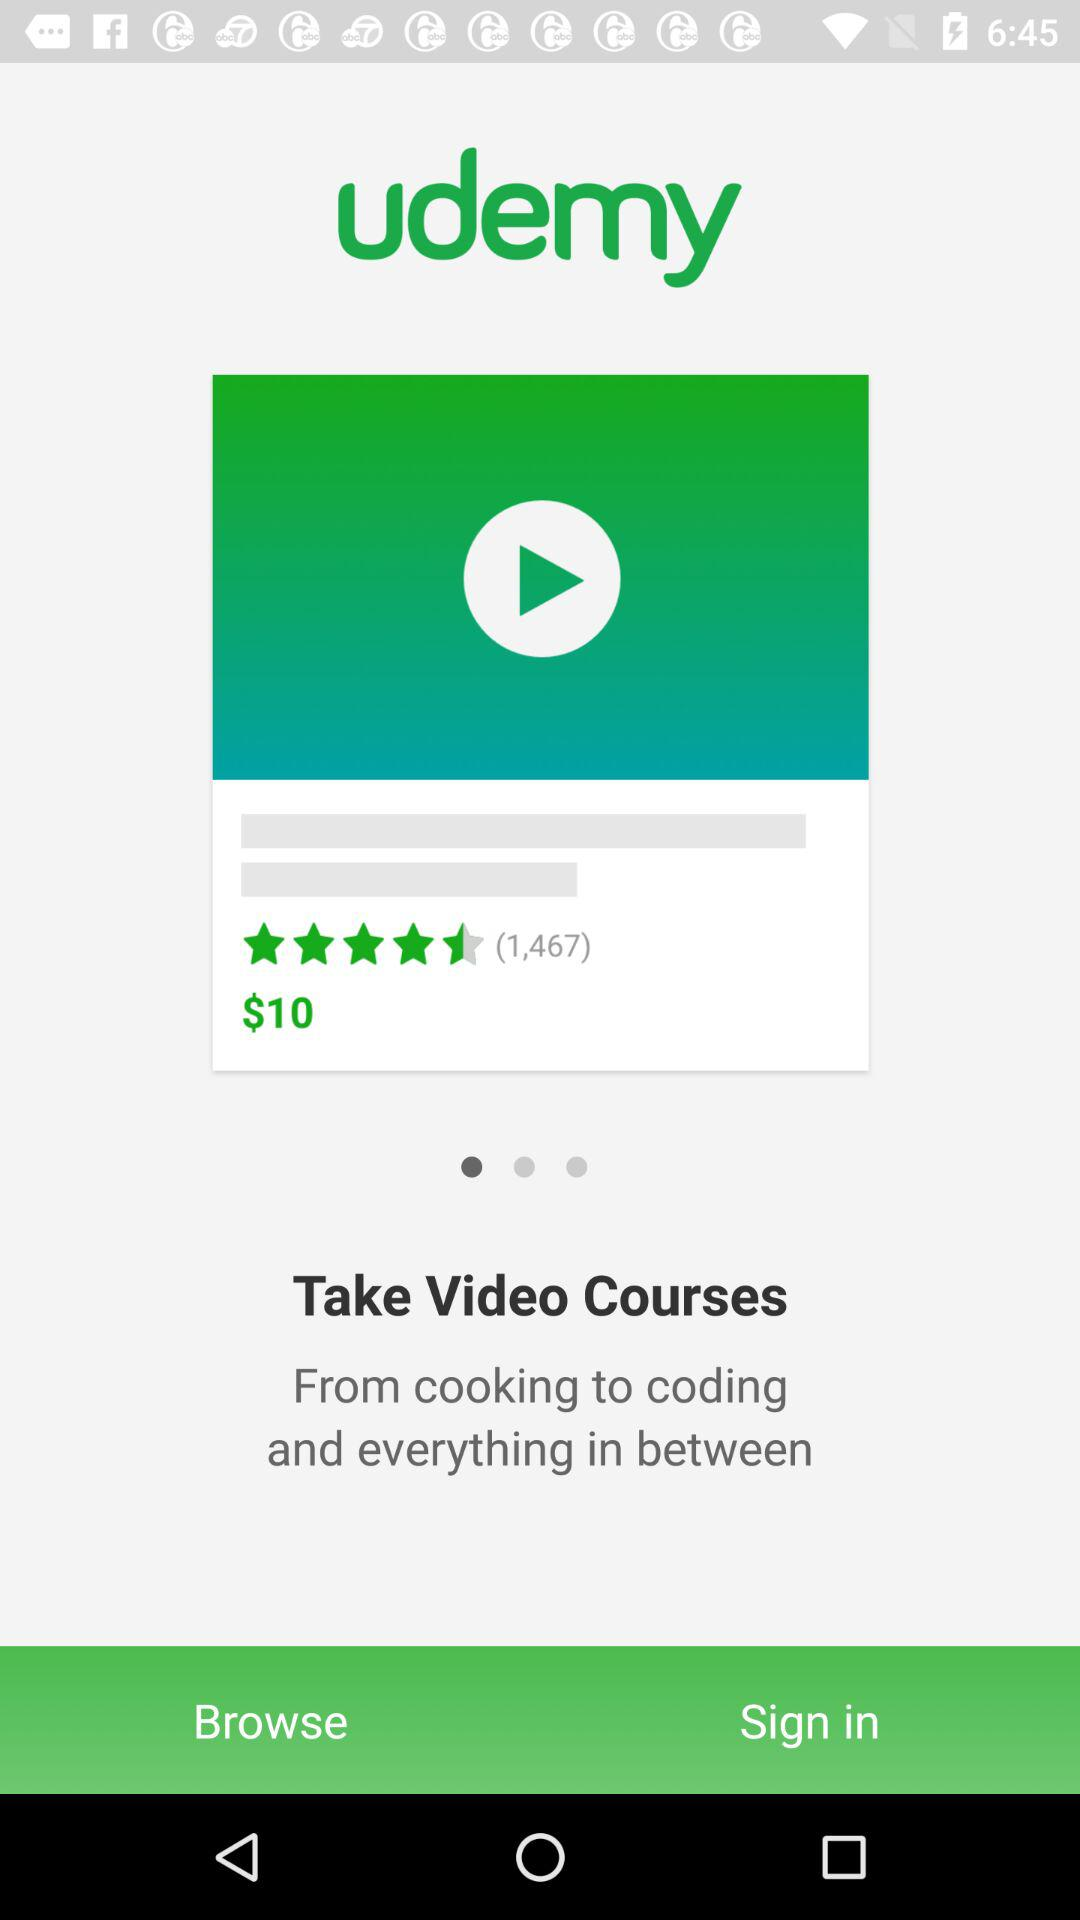How many people liked it? There are a total of 1,467 people who liked it. 